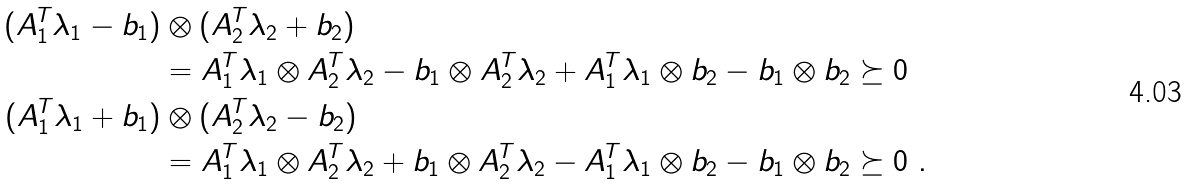Convert formula to latex. <formula><loc_0><loc_0><loc_500><loc_500>( A _ { 1 } ^ { T } \lambda _ { 1 } - b _ { 1 } ) & \otimes ( A _ { 2 } ^ { T } \lambda _ { 2 } + b _ { 2 } ) \\ & = A _ { 1 } ^ { T } \lambda _ { 1 } \otimes A _ { 2 } ^ { T } \lambda _ { 2 } - b _ { 1 } \otimes A _ { 2 } ^ { T } \lambda _ { 2 } + A _ { 1 } ^ { T } \lambda _ { 1 } \otimes b _ { 2 } - b _ { 1 } \otimes b _ { 2 } \succeq 0 \\ ( A _ { 1 } ^ { T } \lambda _ { 1 } + b _ { 1 } ) & \otimes ( A _ { 2 } ^ { T } \lambda _ { 2 } - b _ { 2 } ) \\ & = A _ { 1 } ^ { T } \lambda _ { 1 } \otimes A _ { 2 } ^ { T } \lambda _ { 2 } + b _ { 1 } \otimes A _ { 2 } ^ { T } \lambda _ { 2 } - A _ { 1 } ^ { T } \lambda _ { 1 } \otimes b _ { 2 } - b _ { 1 } \otimes b _ { 2 } \succeq 0 \ .</formula> 